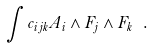<formula> <loc_0><loc_0><loc_500><loc_500>\int c _ { i j k } A _ { i } \wedge F _ { j } \wedge F _ { k } \ .</formula> 